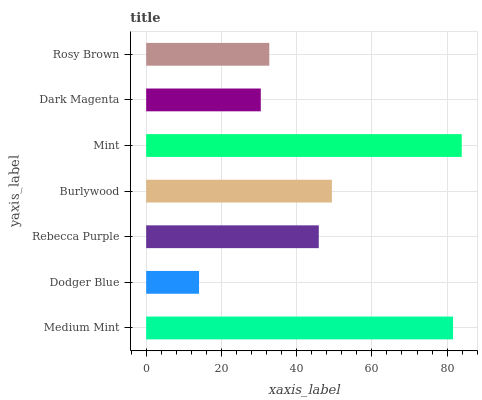Is Dodger Blue the minimum?
Answer yes or no. Yes. Is Mint the maximum?
Answer yes or no. Yes. Is Rebecca Purple the minimum?
Answer yes or no. No. Is Rebecca Purple the maximum?
Answer yes or no. No. Is Rebecca Purple greater than Dodger Blue?
Answer yes or no. Yes. Is Dodger Blue less than Rebecca Purple?
Answer yes or no. Yes. Is Dodger Blue greater than Rebecca Purple?
Answer yes or no. No. Is Rebecca Purple less than Dodger Blue?
Answer yes or no. No. Is Rebecca Purple the high median?
Answer yes or no. Yes. Is Rebecca Purple the low median?
Answer yes or no. Yes. Is Dark Magenta the high median?
Answer yes or no. No. Is Mint the low median?
Answer yes or no. No. 